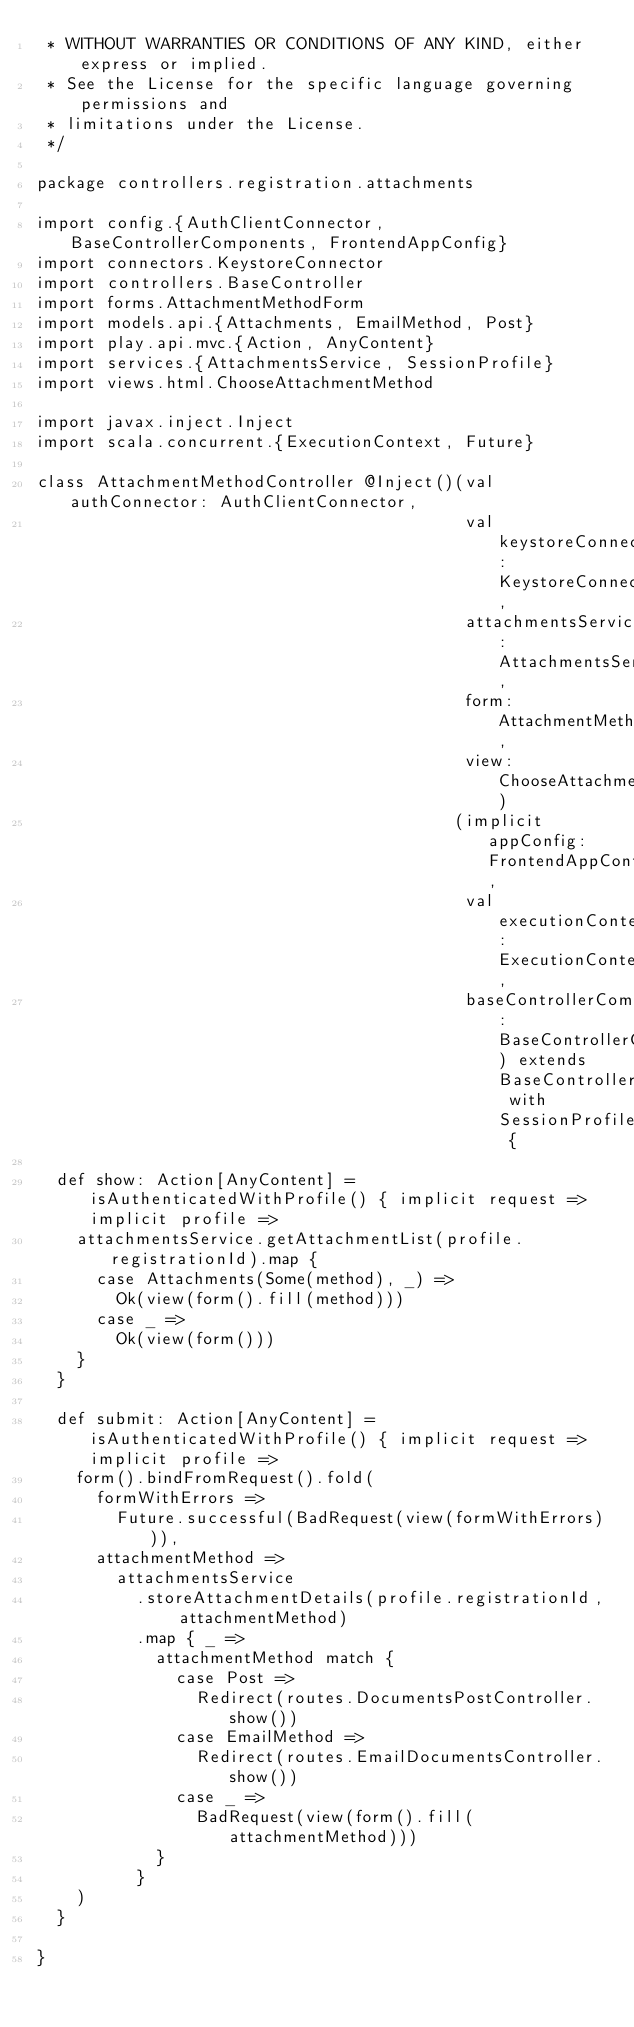Convert code to text. <code><loc_0><loc_0><loc_500><loc_500><_Scala_> * WITHOUT WARRANTIES OR CONDITIONS OF ANY KIND, either express or implied.
 * See the License for the specific language governing permissions and
 * limitations under the License.
 */

package controllers.registration.attachments

import config.{AuthClientConnector, BaseControllerComponents, FrontendAppConfig}
import connectors.KeystoreConnector
import controllers.BaseController
import forms.AttachmentMethodForm
import models.api.{Attachments, EmailMethod, Post}
import play.api.mvc.{Action, AnyContent}
import services.{AttachmentsService, SessionProfile}
import views.html.ChooseAttachmentMethod

import javax.inject.Inject
import scala.concurrent.{ExecutionContext, Future}

class AttachmentMethodController @Inject()(val authConnector: AuthClientConnector,
                                           val keystoreConnector: KeystoreConnector,
                                           attachmentsService: AttachmentsService,
                                           form: AttachmentMethodForm,
                                           view: ChooseAttachmentMethod)
                                          (implicit appConfig: FrontendAppConfig,
                                           val executionContext: ExecutionContext,
                                           baseControllerComponents: BaseControllerComponents) extends BaseController with SessionProfile {

  def show: Action[AnyContent] = isAuthenticatedWithProfile() { implicit request => implicit profile =>
    attachmentsService.getAttachmentList(profile.registrationId).map {
      case Attachments(Some(method), _) =>
        Ok(view(form().fill(method)))
      case _ =>
        Ok(view(form()))
    }
  }

  def submit: Action[AnyContent] = isAuthenticatedWithProfile() { implicit request => implicit profile =>
    form().bindFromRequest().fold(
      formWithErrors =>
        Future.successful(BadRequest(view(formWithErrors))),
      attachmentMethod =>
        attachmentsService
          .storeAttachmentDetails(profile.registrationId, attachmentMethod)
          .map { _ =>
            attachmentMethod match {
              case Post =>
                Redirect(routes.DocumentsPostController.show())
              case EmailMethod =>
                Redirect(routes.EmailDocumentsController.show())
              case _ =>
                BadRequest(view(form().fill(attachmentMethod)))
            }
          }
    )
  }

}
</code> 